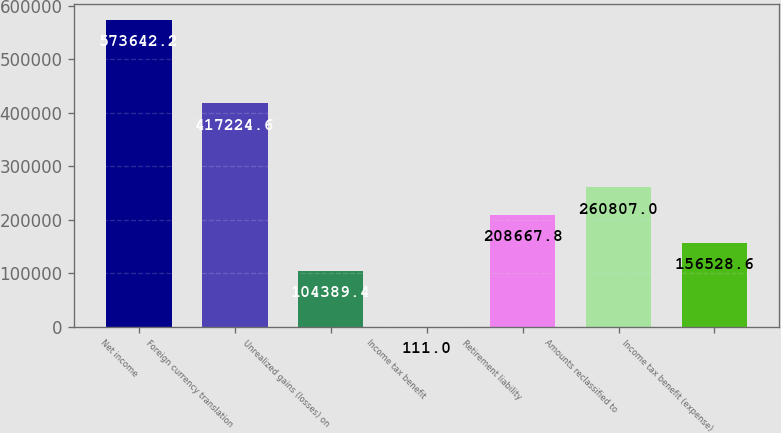Convert chart. <chart><loc_0><loc_0><loc_500><loc_500><bar_chart><fcel>Net income<fcel>Foreign currency translation<fcel>Unrealized gains (losses) on<fcel>Income tax benefit<fcel>Retirement liability<fcel>Amounts reclassified to<fcel>Income tax benefit (expense)<nl><fcel>573642<fcel>417225<fcel>104389<fcel>111<fcel>208668<fcel>260807<fcel>156529<nl></chart> 